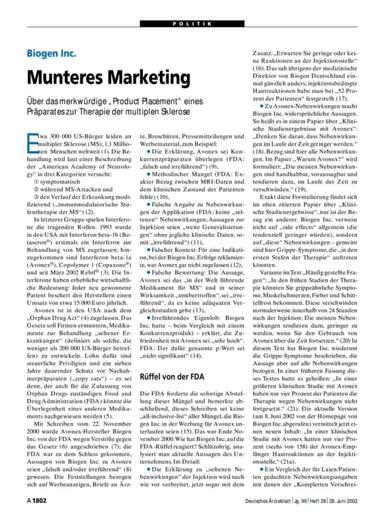Who is mentioned in the text as responsible for marketing a product related to multiple sclerosis therapy? Biogen Inc. is explicitly mentioned in the document as the company responsible for marketing a therapy for multiple sclerosis. This highlights their role in the global healthcare market relating to this particular disease. 